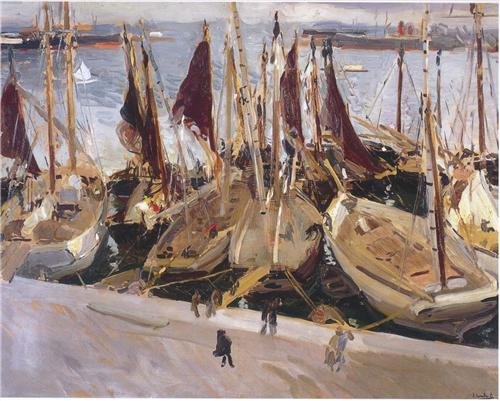Can you describe the mood of this painting and how the artist conveys it? The mood of the painting is lively and bustling, capturing the dynamic energy of a busy harbor. The artist conveys this mood through the use of loose, energetic brushstrokes that create a sense of movement and activity. The choice of colors—predominantly warm tones like beige, white, and red—adds to the vibrancy of the scene. Additionally, the presence of many sailboats moored close together and the depiction of numerous indistinct figures add to the crowded and active atmosphere. The distant, softer cityscape in the background contrasts with the busy foreground, effectively balancing the composition and enhancing the overall mood. 